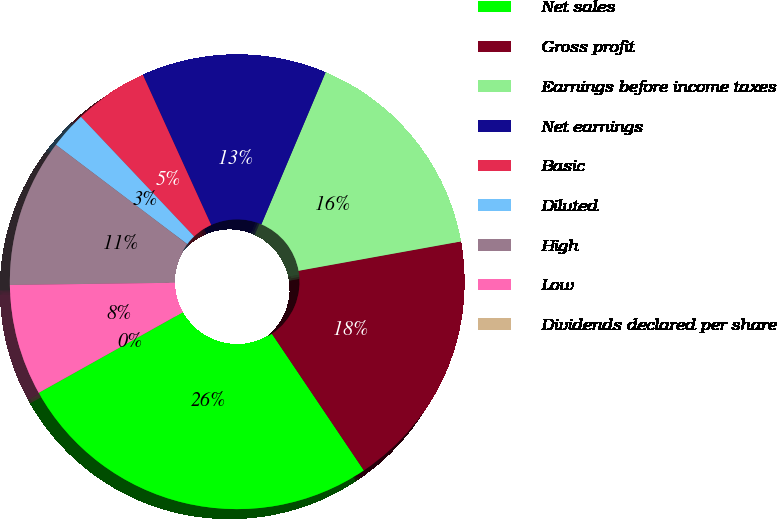Convert chart. <chart><loc_0><loc_0><loc_500><loc_500><pie_chart><fcel>Net sales<fcel>Gross profit<fcel>Earnings before income taxes<fcel>Net earnings<fcel>Basic<fcel>Diluted<fcel>High<fcel>Low<fcel>Dividends declared per share<nl><fcel>26.31%<fcel>18.42%<fcel>15.79%<fcel>13.16%<fcel>5.26%<fcel>2.63%<fcel>10.53%<fcel>7.9%<fcel>0.0%<nl></chart> 